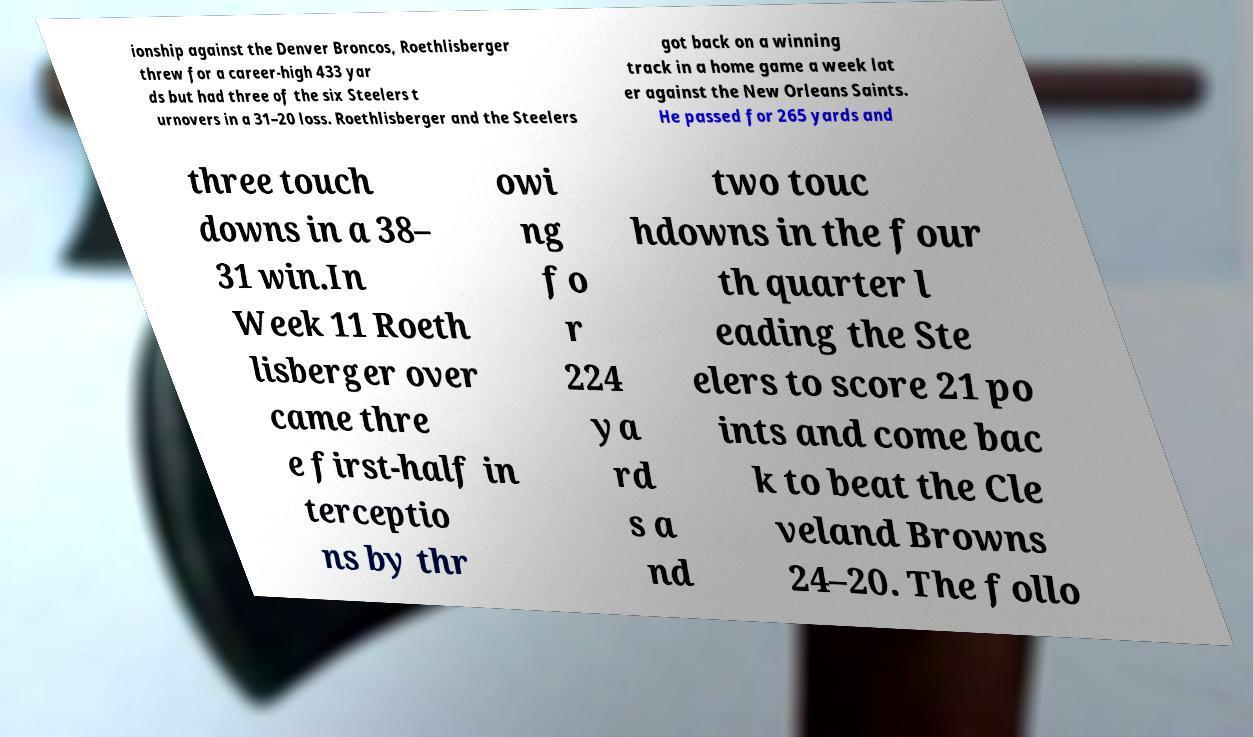There's text embedded in this image that I need extracted. Can you transcribe it verbatim? ionship against the Denver Broncos, Roethlisberger threw for a career-high 433 yar ds but had three of the six Steelers t urnovers in a 31–20 loss. Roethlisberger and the Steelers got back on a winning track in a home game a week lat er against the New Orleans Saints. He passed for 265 yards and three touch downs in a 38– 31 win.In Week 11 Roeth lisberger over came thre e first-half in terceptio ns by thr owi ng fo r 224 ya rd s a nd two touc hdowns in the four th quarter l eading the Ste elers to score 21 po ints and come bac k to beat the Cle veland Browns 24–20. The follo 